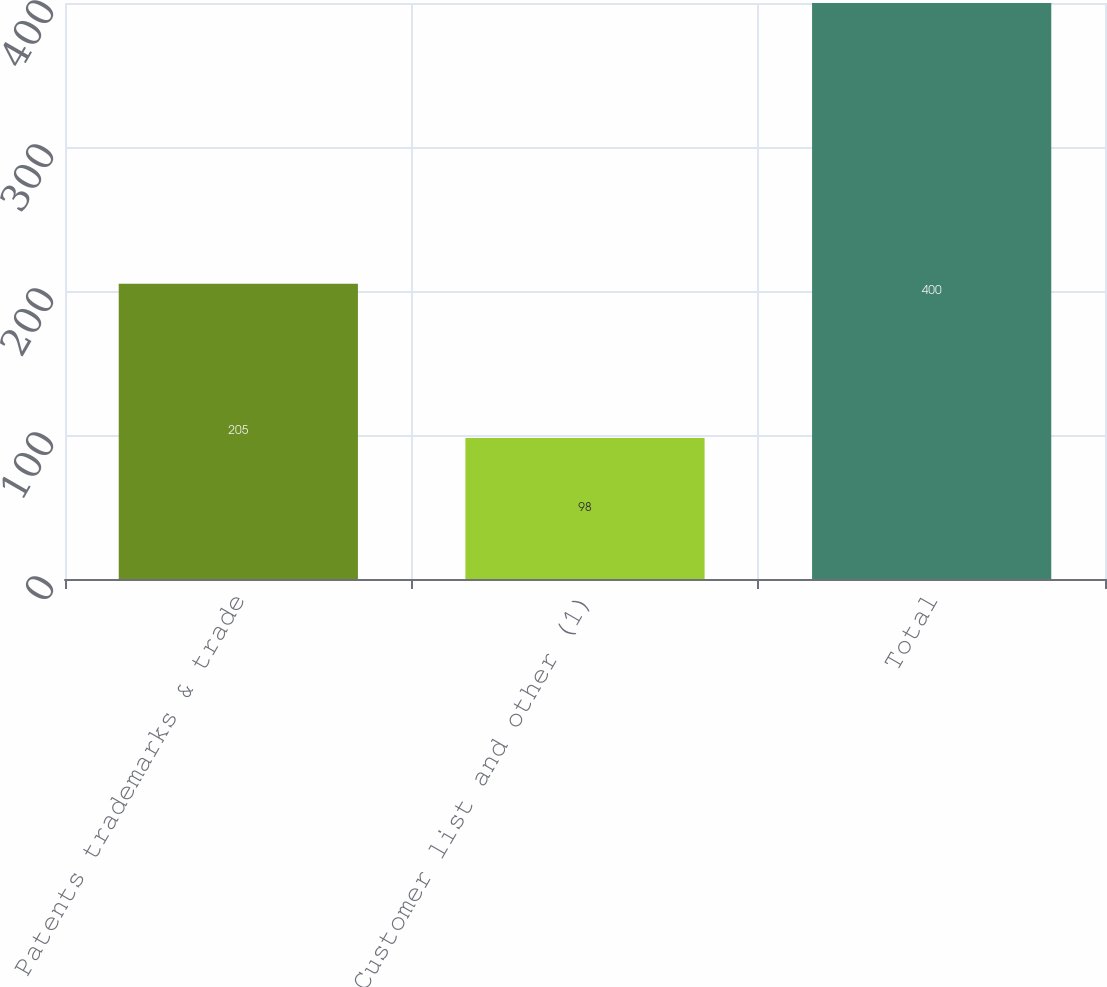Convert chart to OTSL. <chart><loc_0><loc_0><loc_500><loc_500><bar_chart><fcel>Patents trademarks & trade<fcel>Customer list and other (1)<fcel>Total<nl><fcel>205<fcel>98<fcel>400<nl></chart> 